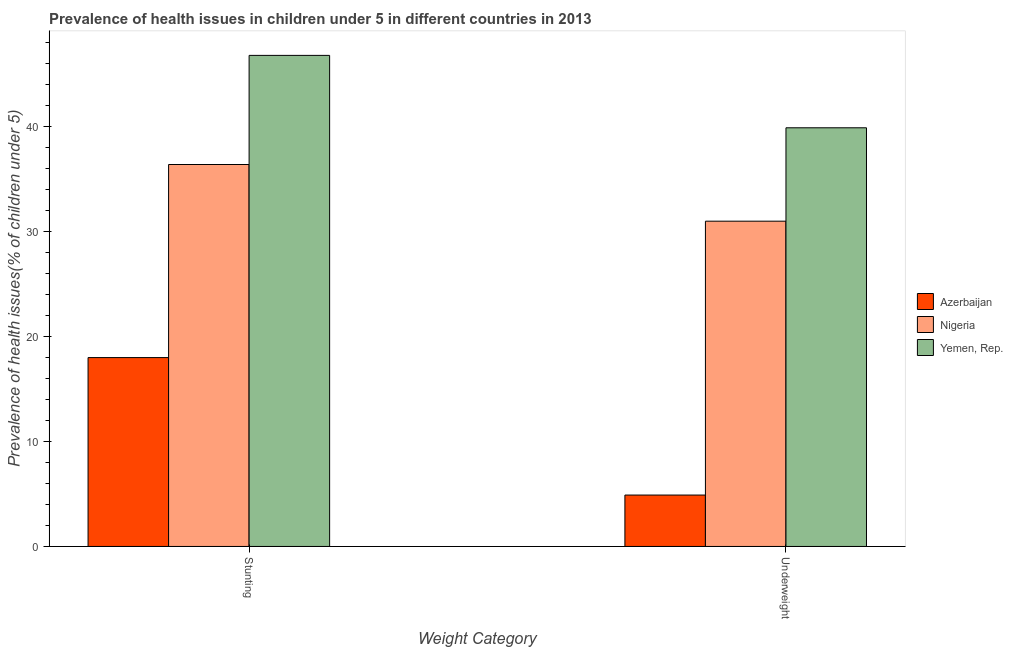How many groups of bars are there?
Provide a succinct answer. 2. Are the number of bars per tick equal to the number of legend labels?
Your answer should be compact. Yes. Are the number of bars on each tick of the X-axis equal?
Your answer should be very brief. Yes. How many bars are there on the 2nd tick from the left?
Provide a short and direct response. 3. How many bars are there on the 1st tick from the right?
Provide a succinct answer. 3. What is the label of the 2nd group of bars from the left?
Your answer should be very brief. Underweight. What is the percentage of stunted children in Nigeria?
Provide a succinct answer. 36.4. Across all countries, what is the maximum percentage of underweight children?
Your answer should be compact. 39.9. Across all countries, what is the minimum percentage of underweight children?
Offer a very short reply. 4.9. In which country was the percentage of underweight children maximum?
Make the answer very short. Yemen, Rep. In which country was the percentage of underweight children minimum?
Make the answer very short. Azerbaijan. What is the total percentage of stunted children in the graph?
Keep it short and to the point. 101.2. What is the difference between the percentage of underweight children in Yemen, Rep. and that in Nigeria?
Offer a very short reply. 8.9. What is the difference between the percentage of stunted children in Yemen, Rep. and the percentage of underweight children in Nigeria?
Offer a terse response. 15.8. What is the average percentage of stunted children per country?
Your response must be concise. 33.73. What is the difference between the percentage of stunted children and percentage of underweight children in Azerbaijan?
Your answer should be compact. 13.1. What is the ratio of the percentage of stunted children in Nigeria to that in Azerbaijan?
Your answer should be very brief. 2.02. In how many countries, is the percentage of stunted children greater than the average percentage of stunted children taken over all countries?
Offer a terse response. 2. What does the 3rd bar from the left in Underweight represents?
Ensure brevity in your answer.  Yemen, Rep. What does the 2nd bar from the right in Stunting represents?
Make the answer very short. Nigeria. Are all the bars in the graph horizontal?
Offer a very short reply. No. What is the difference between two consecutive major ticks on the Y-axis?
Offer a terse response. 10. Are the values on the major ticks of Y-axis written in scientific E-notation?
Provide a short and direct response. No. Does the graph contain any zero values?
Your answer should be compact. No. Does the graph contain grids?
Your answer should be compact. No. Where does the legend appear in the graph?
Give a very brief answer. Center right. How are the legend labels stacked?
Offer a very short reply. Vertical. What is the title of the graph?
Provide a succinct answer. Prevalence of health issues in children under 5 in different countries in 2013. What is the label or title of the X-axis?
Your answer should be very brief. Weight Category. What is the label or title of the Y-axis?
Provide a succinct answer. Prevalence of health issues(% of children under 5). What is the Prevalence of health issues(% of children under 5) in Azerbaijan in Stunting?
Keep it short and to the point. 18. What is the Prevalence of health issues(% of children under 5) in Nigeria in Stunting?
Give a very brief answer. 36.4. What is the Prevalence of health issues(% of children under 5) of Yemen, Rep. in Stunting?
Offer a terse response. 46.8. What is the Prevalence of health issues(% of children under 5) of Azerbaijan in Underweight?
Offer a very short reply. 4.9. What is the Prevalence of health issues(% of children under 5) of Nigeria in Underweight?
Offer a very short reply. 31. What is the Prevalence of health issues(% of children under 5) of Yemen, Rep. in Underweight?
Offer a very short reply. 39.9. Across all Weight Category, what is the maximum Prevalence of health issues(% of children under 5) of Nigeria?
Your response must be concise. 36.4. Across all Weight Category, what is the maximum Prevalence of health issues(% of children under 5) of Yemen, Rep.?
Keep it short and to the point. 46.8. Across all Weight Category, what is the minimum Prevalence of health issues(% of children under 5) in Azerbaijan?
Ensure brevity in your answer.  4.9. Across all Weight Category, what is the minimum Prevalence of health issues(% of children under 5) of Nigeria?
Provide a short and direct response. 31. Across all Weight Category, what is the minimum Prevalence of health issues(% of children under 5) in Yemen, Rep.?
Ensure brevity in your answer.  39.9. What is the total Prevalence of health issues(% of children under 5) of Azerbaijan in the graph?
Give a very brief answer. 22.9. What is the total Prevalence of health issues(% of children under 5) of Nigeria in the graph?
Offer a terse response. 67.4. What is the total Prevalence of health issues(% of children under 5) in Yemen, Rep. in the graph?
Provide a short and direct response. 86.7. What is the difference between the Prevalence of health issues(% of children under 5) of Nigeria in Stunting and that in Underweight?
Make the answer very short. 5.4. What is the difference between the Prevalence of health issues(% of children under 5) in Azerbaijan in Stunting and the Prevalence of health issues(% of children under 5) in Nigeria in Underweight?
Give a very brief answer. -13. What is the difference between the Prevalence of health issues(% of children under 5) of Azerbaijan in Stunting and the Prevalence of health issues(% of children under 5) of Yemen, Rep. in Underweight?
Your answer should be compact. -21.9. What is the difference between the Prevalence of health issues(% of children under 5) in Nigeria in Stunting and the Prevalence of health issues(% of children under 5) in Yemen, Rep. in Underweight?
Provide a succinct answer. -3.5. What is the average Prevalence of health issues(% of children under 5) of Azerbaijan per Weight Category?
Your answer should be compact. 11.45. What is the average Prevalence of health issues(% of children under 5) of Nigeria per Weight Category?
Provide a short and direct response. 33.7. What is the average Prevalence of health issues(% of children under 5) in Yemen, Rep. per Weight Category?
Keep it short and to the point. 43.35. What is the difference between the Prevalence of health issues(% of children under 5) of Azerbaijan and Prevalence of health issues(% of children under 5) of Nigeria in Stunting?
Offer a terse response. -18.4. What is the difference between the Prevalence of health issues(% of children under 5) of Azerbaijan and Prevalence of health issues(% of children under 5) of Yemen, Rep. in Stunting?
Provide a short and direct response. -28.8. What is the difference between the Prevalence of health issues(% of children under 5) of Nigeria and Prevalence of health issues(% of children under 5) of Yemen, Rep. in Stunting?
Provide a short and direct response. -10.4. What is the difference between the Prevalence of health issues(% of children under 5) in Azerbaijan and Prevalence of health issues(% of children under 5) in Nigeria in Underweight?
Offer a terse response. -26.1. What is the difference between the Prevalence of health issues(% of children under 5) in Azerbaijan and Prevalence of health issues(% of children under 5) in Yemen, Rep. in Underweight?
Provide a succinct answer. -35. What is the difference between the Prevalence of health issues(% of children under 5) in Nigeria and Prevalence of health issues(% of children under 5) in Yemen, Rep. in Underweight?
Your answer should be very brief. -8.9. What is the ratio of the Prevalence of health issues(% of children under 5) in Azerbaijan in Stunting to that in Underweight?
Give a very brief answer. 3.67. What is the ratio of the Prevalence of health issues(% of children under 5) in Nigeria in Stunting to that in Underweight?
Give a very brief answer. 1.17. What is the ratio of the Prevalence of health issues(% of children under 5) in Yemen, Rep. in Stunting to that in Underweight?
Give a very brief answer. 1.17. What is the difference between the highest and the second highest Prevalence of health issues(% of children under 5) in Azerbaijan?
Give a very brief answer. 13.1. What is the difference between the highest and the second highest Prevalence of health issues(% of children under 5) in Nigeria?
Keep it short and to the point. 5.4. What is the difference between the highest and the second highest Prevalence of health issues(% of children under 5) of Yemen, Rep.?
Provide a short and direct response. 6.9. What is the difference between the highest and the lowest Prevalence of health issues(% of children under 5) in Nigeria?
Your answer should be compact. 5.4. What is the difference between the highest and the lowest Prevalence of health issues(% of children under 5) in Yemen, Rep.?
Offer a terse response. 6.9. 